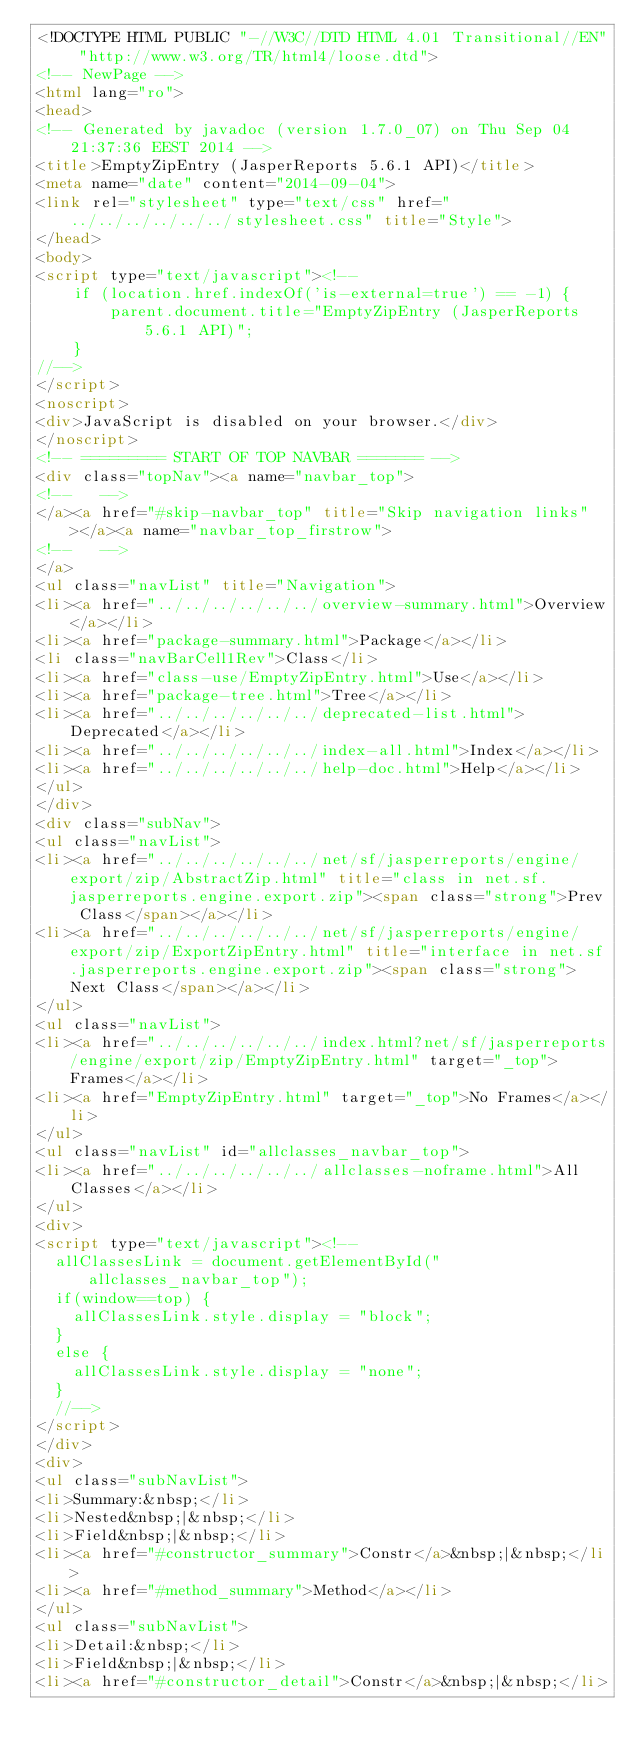<code> <loc_0><loc_0><loc_500><loc_500><_HTML_><!DOCTYPE HTML PUBLIC "-//W3C//DTD HTML 4.01 Transitional//EN" "http://www.w3.org/TR/html4/loose.dtd">
<!-- NewPage -->
<html lang="ro">
<head>
<!-- Generated by javadoc (version 1.7.0_07) on Thu Sep 04 21:37:36 EEST 2014 -->
<title>EmptyZipEntry (JasperReports 5.6.1 API)</title>
<meta name="date" content="2014-09-04">
<link rel="stylesheet" type="text/css" href="../../../../../../stylesheet.css" title="Style">
</head>
<body>
<script type="text/javascript"><!--
    if (location.href.indexOf('is-external=true') == -1) {
        parent.document.title="EmptyZipEntry (JasperReports 5.6.1 API)";
    }
//-->
</script>
<noscript>
<div>JavaScript is disabled on your browser.</div>
</noscript>
<!-- ========= START OF TOP NAVBAR ======= -->
<div class="topNav"><a name="navbar_top">
<!--   -->
</a><a href="#skip-navbar_top" title="Skip navigation links"></a><a name="navbar_top_firstrow">
<!--   -->
</a>
<ul class="navList" title="Navigation">
<li><a href="../../../../../../overview-summary.html">Overview</a></li>
<li><a href="package-summary.html">Package</a></li>
<li class="navBarCell1Rev">Class</li>
<li><a href="class-use/EmptyZipEntry.html">Use</a></li>
<li><a href="package-tree.html">Tree</a></li>
<li><a href="../../../../../../deprecated-list.html">Deprecated</a></li>
<li><a href="../../../../../../index-all.html">Index</a></li>
<li><a href="../../../../../../help-doc.html">Help</a></li>
</ul>
</div>
<div class="subNav">
<ul class="navList">
<li><a href="../../../../../../net/sf/jasperreports/engine/export/zip/AbstractZip.html" title="class in net.sf.jasperreports.engine.export.zip"><span class="strong">Prev Class</span></a></li>
<li><a href="../../../../../../net/sf/jasperreports/engine/export/zip/ExportZipEntry.html" title="interface in net.sf.jasperreports.engine.export.zip"><span class="strong">Next Class</span></a></li>
</ul>
<ul class="navList">
<li><a href="../../../../../../index.html?net/sf/jasperreports/engine/export/zip/EmptyZipEntry.html" target="_top">Frames</a></li>
<li><a href="EmptyZipEntry.html" target="_top">No Frames</a></li>
</ul>
<ul class="navList" id="allclasses_navbar_top">
<li><a href="../../../../../../allclasses-noframe.html">All Classes</a></li>
</ul>
<div>
<script type="text/javascript"><!--
  allClassesLink = document.getElementById("allclasses_navbar_top");
  if(window==top) {
    allClassesLink.style.display = "block";
  }
  else {
    allClassesLink.style.display = "none";
  }
  //-->
</script>
</div>
<div>
<ul class="subNavList">
<li>Summary:&nbsp;</li>
<li>Nested&nbsp;|&nbsp;</li>
<li>Field&nbsp;|&nbsp;</li>
<li><a href="#constructor_summary">Constr</a>&nbsp;|&nbsp;</li>
<li><a href="#method_summary">Method</a></li>
</ul>
<ul class="subNavList">
<li>Detail:&nbsp;</li>
<li>Field&nbsp;|&nbsp;</li>
<li><a href="#constructor_detail">Constr</a>&nbsp;|&nbsp;</li></code> 